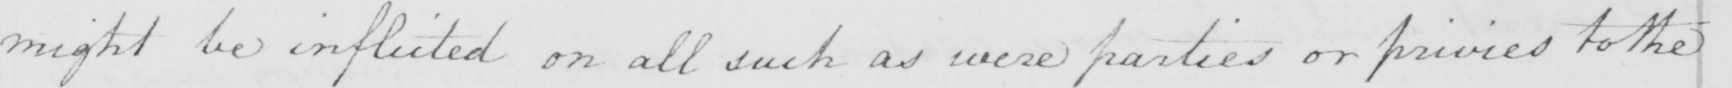Transcribe the text shown in this historical manuscript line. might be inflicted on all such as were parties or privies to the 